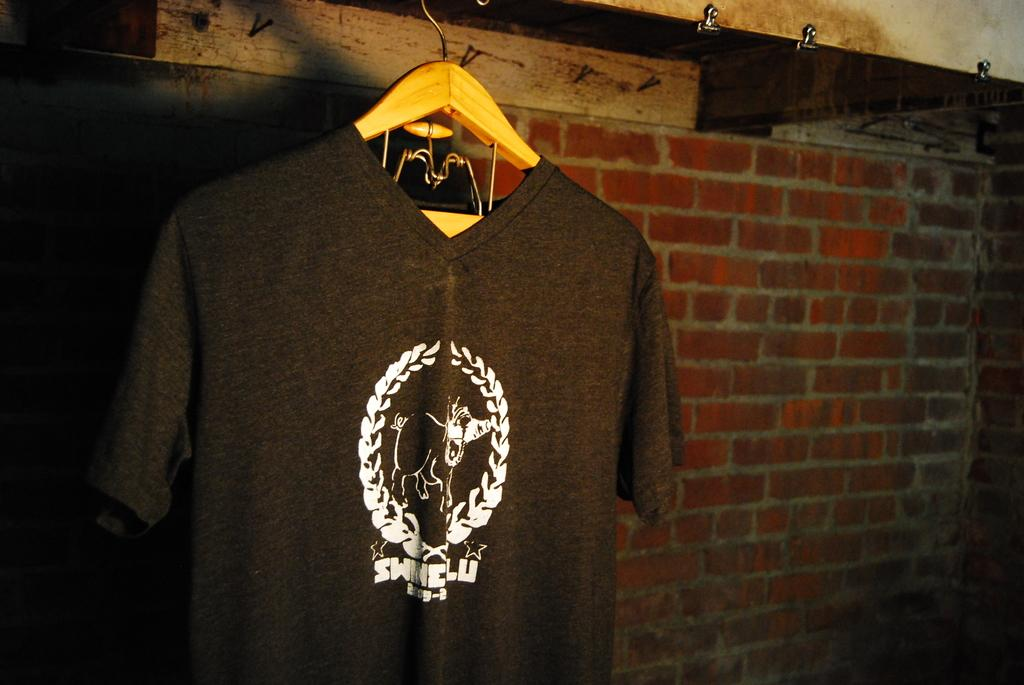What is hanging in the image? There is a shirt in the image, and it is hanged on a hanger. What can be seen in the background of the image? There is a brick wall in the background of the image. What time does the clock show in the image? There is no clock present in the image. How much debt is associated with the shirt in the image? There is no mention of debt in the image, as it only features a shirt hanging on a hanger in front of a brick wall. 